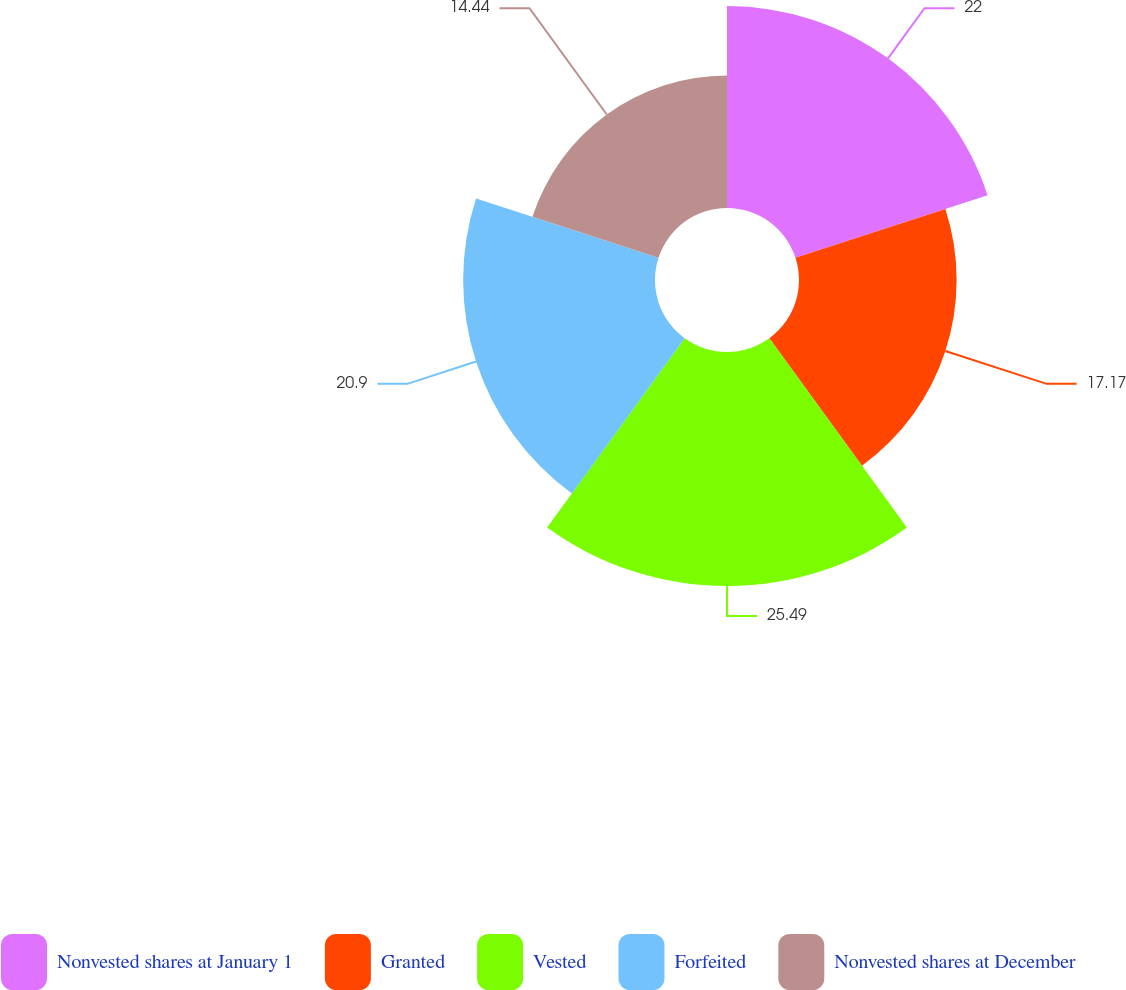Convert chart to OTSL. <chart><loc_0><loc_0><loc_500><loc_500><pie_chart><fcel>Nonvested shares at January 1<fcel>Granted<fcel>Vested<fcel>Forfeited<fcel>Nonvested shares at December<nl><fcel>22.0%<fcel>17.17%<fcel>25.49%<fcel>20.9%<fcel>14.44%<nl></chart> 